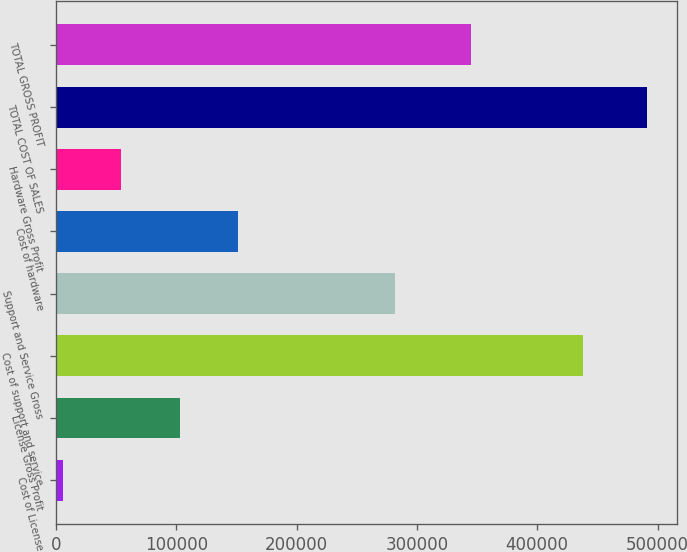Convert chart to OTSL. <chart><loc_0><loc_0><loc_500><loc_500><bar_chart><fcel>Cost of License<fcel>License Gross Profit<fcel>Cost of support and service<fcel>Support and Service Gross<fcel>Cost of hardware<fcel>Hardware Gross Profit<fcel>TOTAL COST OF SALES<fcel>TOTAL GROSS PROFIT<nl><fcel>5827<fcel>102955<fcel>438476<fcel>282028<fcel>151519<fcel>54390.9<fcel>491466<fcel>345120<nl></chart> 